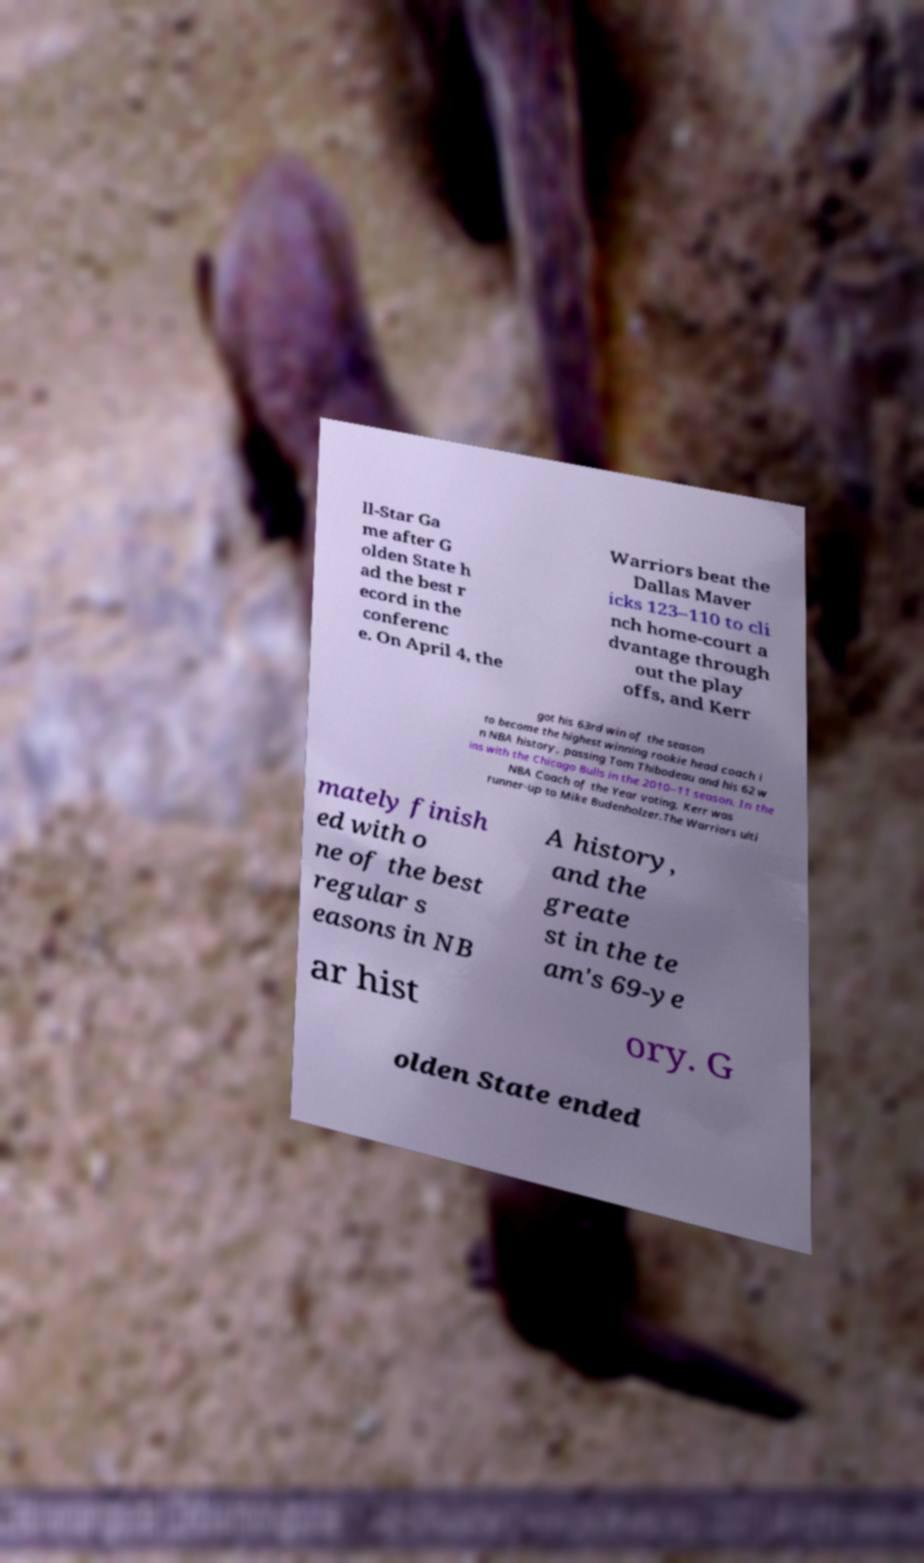Can you read and provide the text displayed in the image?This photo seems to have some interesting text. Can you extract and type it out for me? ll-Star Ga me after G olden State h ad the best r ecord in the conferenc e. On April 4, the Warriors beat the Dallas Maver icks 123–110 to cli nch home-court a dvantage through out the play offs, and Kerr got his 63rd win of the season to become the highest winning rookie head coach i n NBA history, passing Tom Thibodeau and his 62 w ins with the Chicago Bulls in the 2010–11 season. In the NBA Coach of the Year voting, Kerr was runner-up to Mike Budenholzer.The Warriors ulti mately finish ed with o ne of the best regular s easons in NB A history, and the greate st in the te am's 69-ye ar hist ory. G olden State ended 